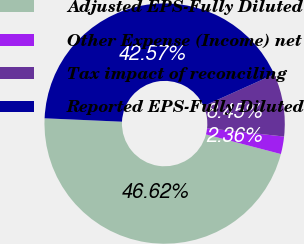Convert chart to OTSL. <chart><loc_0><loc_0><loc_500><loc_500><pie_chart><fcel>Adjusted EPS-Fully Diluted<fcel>Other Expense (Income) net<fcel>Tax impact of reconciling<fcel>Reported EPS-Fully Diluted<nl><fcel>46.62%<fcel>2.36%<fcel>8.45%<fcel>42.57%<nl></chart> 